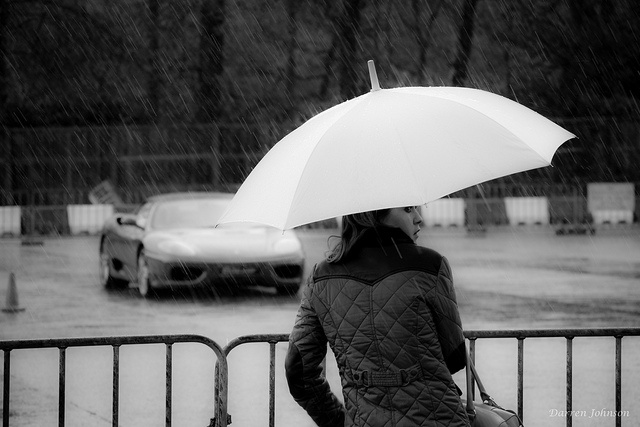Describe the objects in this image and their specific colors. I can see umbrella in black, lightgray, darkgray, and gray tones, people in black, gray, darkgray, and lightgray tones, car in black, lightgray, darkgray, and gray tones, and handbag in black, gray, darkgray, and lightgray tones in this image. 